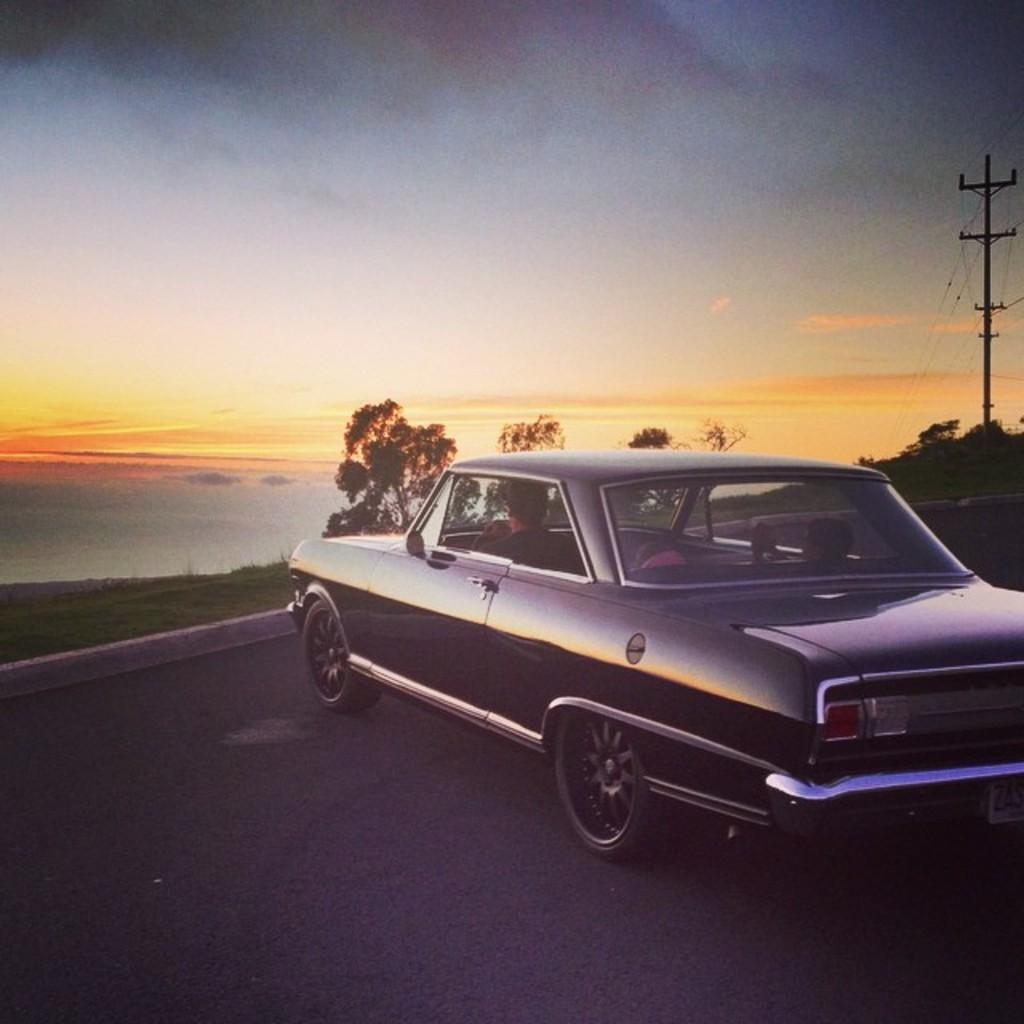How many people are in the car in the image? There are two persons sitting in a car in the image. Where is the car located? The car is on the road in the image. What type of vegetation can be seen in the image? There are trees and grass in the image. What other structures are present in the image? There are poles and wires in the image. What is visible in the background of the image? The sky is visible in the image. What day of the week is it in the image? The day of the week is not mentioned or visible in the image. What is in the pocket of the person sitting in the passenger seat? There is no information about pockets or their contents in the image. 